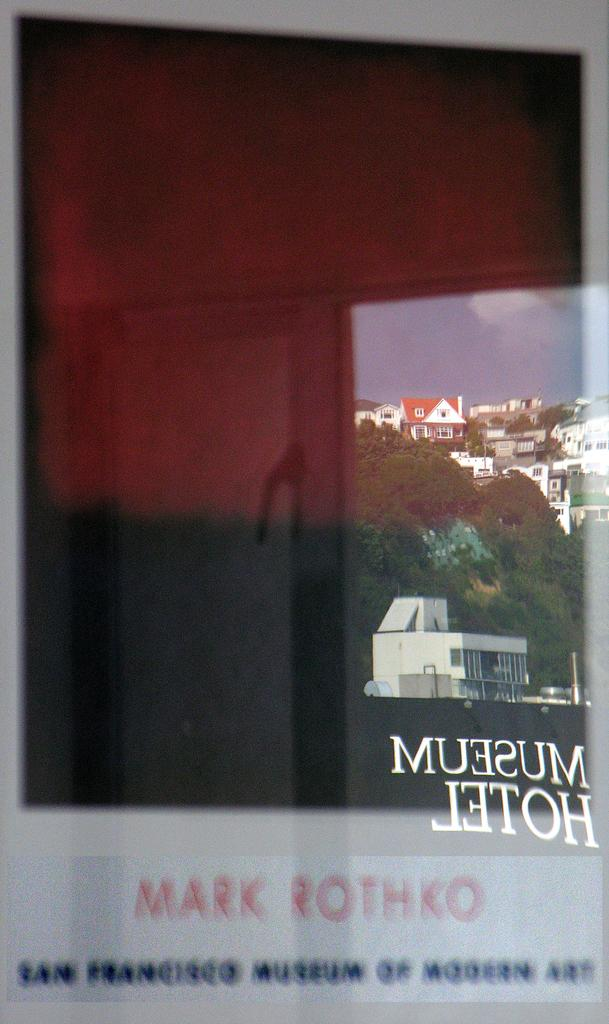What object is present in the image that has reflections on it? There is a glass in the image that has reflections on it. What types of objects can be seen reflecting on the glass? Houses, trees, and the sky are reflecting on the glass. What color is the elbow of the person holding the glass in the image? There is no person holding the glass in the image, so it is not possible to determine the color of their elbow. 